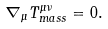Convert formula to latex. <formula><loc_0><loc_0><loc_500><loc_500>\nabla _ { \mu } T _ { m a s s } ^ { \mu \nu } = 0 .</formula> 